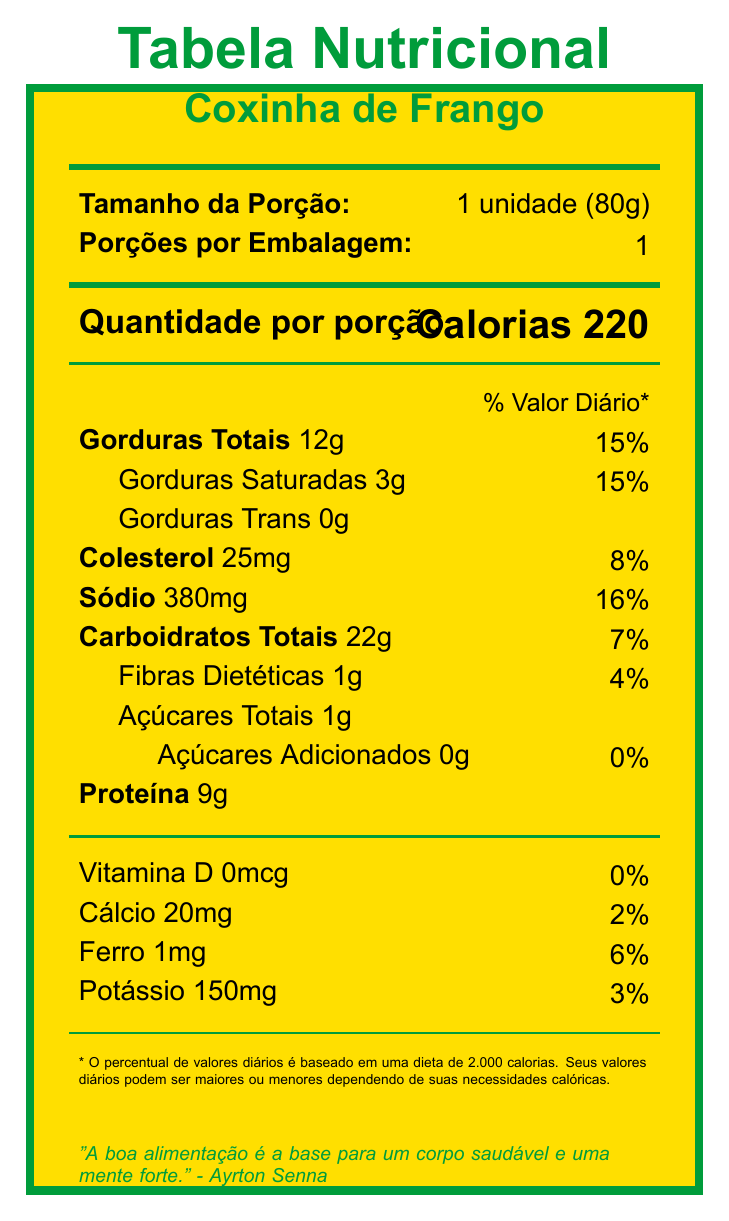what is the serving size for Coxinha de Frango? The serving size is explicitly mentioned in the document as "1 unidade (80g)".
Answer: 1 unidade (80g) how many calories are there in one serving of Coxinha de Frango? The document states that there are 220 calories per serving.
Answer: 220 what is the percentage of daily value for total fat in one serving? The document lists the percentage of daily value for total fat as 15%.
Answer: 15% what are the allergens listed in the document? The document specifies allergens as Wheat and Milk in the additional information section.
Answer: Wheat, Milk what is the cultural significance of Coxinha de Frango? The document mentions that Coxinha de Frango is a traditional snack often enjoyed during football matches.
Answer: Traditional snack often enjoyed during football matches what is the recommended pre-workout timing for consuming Coxinha de Frango? A. Immediately after exercise B. 30 minutes before exercise C. 2-3 hours before exercise D. Anytime during the day The document recommends consuming Coxinha de Frango 2-3 hours before exercise.
Answer: C how much protein is contained in one serving of Coxinha de Frango? The document states that there are 9g of protein per serving.
Answer: 9g which vitamin is reported in the document with 0% daily value? The document lists Vitamin D with 0% daily value.
Answer: Vitamin D what amount of dietary fiber is present in one serving? The document states that there is 1g of dietary fiber per serving.
Answer: 1g is there any trans fat in Coxinha de Frango? The document states that there is 0g of trans fat.
Answer: No how many minerals are listed with a percentage of daily value in the document? The minerals listed with a percentage of daily value are Calcium, Iron, Potassium, and Sodium.
Answer: Four based on the document, what is a healthy alternative cooking method suggested? The document suggests baking instead of deep-frying as a healthier alternative, as recommended by nutricionista Drauzio Varella.
Answer: Baking instead of deep-frying what would be a balanced meal suggestion to pair with Coxinha de Frango? The document suggests pairing Coxinha de Frango with a mixed green salad and fresh fruit for a more balanced meal.
Answer: Pair with a mixed green salad and fresh fruit what is the manufacturer's name of Coxinha de Frango? The document states that the manufacturer's name is Coxinhas do Pelé.
Answer: Coxinhas do Pelé describe the main idea of the document. The document provides comprehensive nutritional information, allergen warnings, and cultural context for the food item Coxinha de Frango, aiming to inform fitness-conscious Brazilians about its consumption.
Answer: The document is a Nutrition Facts Label for Coxinha de Frango, detailing serving size, calorie content, macronutrients, micronutrients, allergens, and additional fitness-oriented and culturally significant information. which certifications are mentioned for Coxinha de Frango? A. ANVISA B. ISO 9001 C. SIF D. BRC E. HALAL The document lists ANVISA and SIF as the certifications for Coxinha de Frango.
Answer: A, C what are the popular pairings for Coxinha de Frango? The document mentions that Coxinha de Frango is popularly paired with Guaraná Antarctica or fresh açaí juice.
Answer: Guaraná Antarctica or fresh açaí juice which regional variation of the Coxinha recipe is mentioned in the document? The document states that the Coxinha recipe is from São Paulo.
Answer: Recipe from São Paulo does the document specify enough information about the vitamin C content? The document does not mention the vitamin C content, so it cannot be determined.
Answer: No which inspirational quote is shared in the document? The document includes an inspirational quote by Ayrton Senna about the importance of good nutrition.
Answer: "A boa alimentação é a base para um corpo saudável e uma mente forte." - Ayrton Senna 